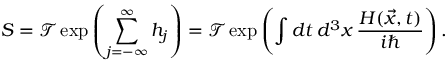<formula> <loc_0><loc_0><loc_500><loc_500>S = { \mathcal { T } } \exp \left ( \sum _ { j = - \infty } ^ { \infty } h _ { j } \right ) = { \mathcal { T } } \exp \left ( \int d t \, d ^ { 3 } x \, { \frac { H ( { \vec { x } } , t ) } { i } } \right ) .</formula> 